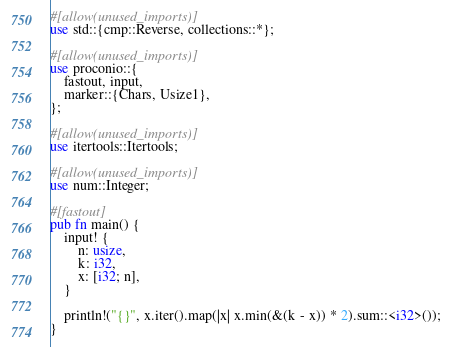Convert code to text. <code><loc_0><loc_0><loc_500><loc_500><_Rust_>#[allow(unused_imports)]
use std::{cmp::Reverse, collections::*};

#[allow(unused_imports)]
use proconio::{
    fastout, input,
    marker::{Chars, Usize1},
};

#[allow(unused_imports)]
use itertools::Itertools;

#[allow(unused_imports)]
use num::Integer;

#[fastout]
pub fn main() {
    input! {
        n: usize,
        k: i32,
        x: [i32; n],
    }

    println!("{}", x.iter().map(|x| x.min(&(k - x)) * 2).sum::<i32>());
}
</code> 